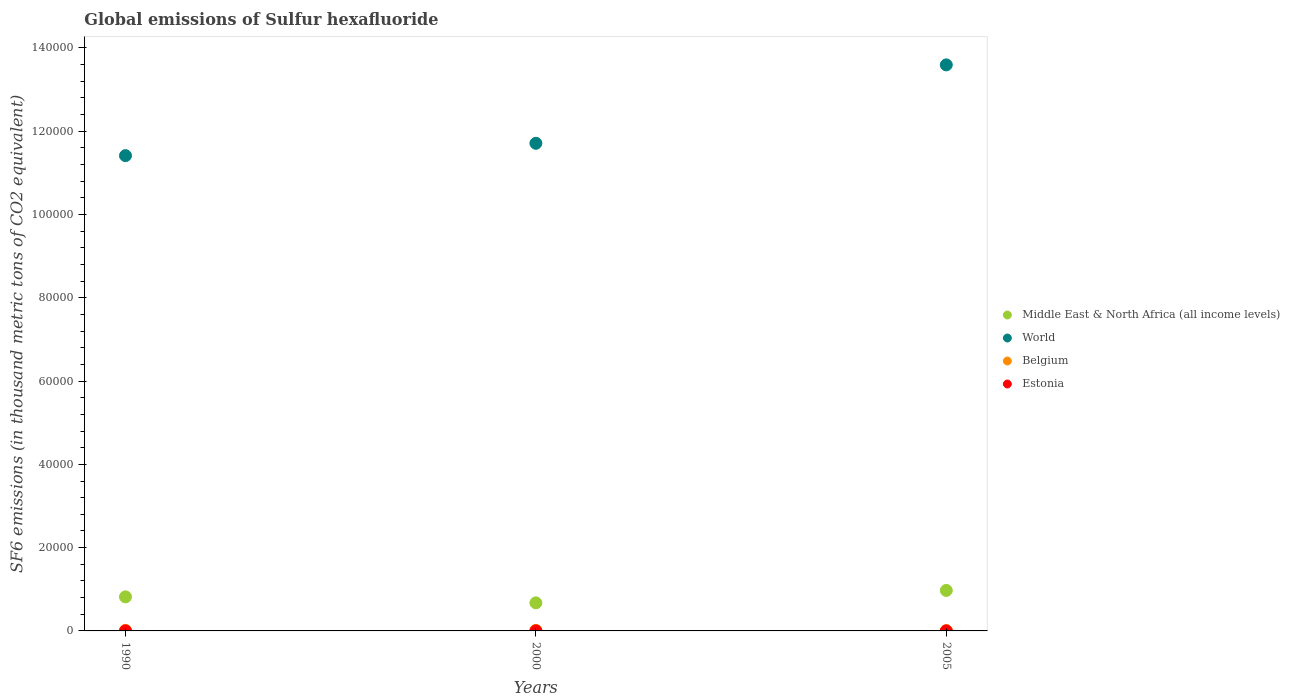Is the number of dotlines equal to the number of legend labels?
Keep it short and to the point. Yes. What is the global emissions of Sulfur hexafluoride in Belgium in 2000?
Offer a terse response. 131.7. Across all years, what is the maximum global emissions of Sulfur hexafluoride in World?
Make the answer very short. 1.36e+05. Across all years, what is the minimum global emissions of Sulfur hexafluoride in Middle East & North Africa (all income levels)?
Your answer should be very brief. 6738.5. In which year was the global emissions of Sulfur hexafluoride in World minimum?
Provide a succinct answer. 1990. What is the total global emissions of Sulfur hexafluoride in Belgium in the graph?
Your answer should be compact. 343.1. What is the difference between the global emissions of Sulfur hexafluoride in Estonia in 1990 and that in 2005?
Offer a very short reply. -0.6. What is the difference between the global emissions of Sulfur hexafluoride in Estonia in 2000 and the global emissions of Sulfur hexafluoride in World in 1990?
Offer a very short reply. -1.14e+05. What is the average global emissions of Sulfur hexafluoride in Belgium per year?
Give a very brief answer. 114.37. In the year 1990, what is the difference between the global emissions of Sulfur hexafluoride in Middle East & North Africa (all income levels) and global emissions of Sulfur hexafluoride in Estonia?
Make the answer very short. 8178.1. What is the ratio of the global emissions of Sulfur hexafluoride in World in 1990 to that in 2005?
Your answer should be compact. 0.84. Is the global emissions of Sulfur hexafluoride in Middle East & North Africa (all income levels) in 1990 less than that in 2000?
Offer a very short reply. No. Is the difference between the global emissions of Sulfur hexafluoride in Middle East & North Africa (all income levels) in 1990 and 2000 greater than the difference between the global emissions of Sulfur hexafluoride in Estonia in 1990 and 2000?
Keep it short and to the point. Yes. What is the difference between the highest and the second highest global emissions of Sulfur hexafluoride in Belgium?
Offer a very short reply. 6.8. What is the difference between the highest and the lowest global emissions of Sulfur hexafluoride in Belgium?
Make the answer very short. 65.6. Is the sum of the global emissions of Sulfur hexafluoride in Belgium in 1990 and 2000 greater than the maximum global emissions of Sulfur hexafluoride in Estonia across all years?
Your answer should be very brief. Yes. Is the global emissions of Sulfur hexafluoride in Belgium strictly greater than the global emissions of Sulfur hexafluoride in Estonia over the years?
Your response must be concise. Yes. Is the global emissions of Sulfur hexafluoride in World strictly less than the global emissions of Sulfur hexafluoride in Belgium over the years?
Keep it short and to the point. No. What is the difference between two consecutive major ticks on the Y-axis?
Keep it short and to the point. 2.00e+04. Are the values on the major ticks of Y-axis written in scientific E-notation?
Make the answer very short. No. Does the graph contain any zero values?
Make the answer very short. No. Does the graph contain grids?
Your answer should be very brief. No. Where does the legend appear in the graph?
Ensure brevity in your answer.  Center right. How many legend labels are there?
Provide a succinct answer. 4. How are the legend labels stacked?
Give a very brief answer. Vertical. What is the title of the graph?
Give a very brief answer. Global emissions of Sulfur hexafluoride. Does "Saudi Arabia" appear as one of the legend labels in the graph?
Offer a very short reply. No. What is the label or title of the X-axis?
Offer a terse response. Years. What is the label or title of the Y-axis?
Make the answer very short. SF6 emissions (in thousand metric tons of CO2 equivalent). What is the SF6 emissions (in thousand metric tons of CO2 equivalent) in Middle East & North Africa (all income levels) in 1990?
Your answer should be very brief. 8179.7. What is the SF6 emissions (in thousand metric tons of CO2 equivalent) of World in 1990?
Offer a very short reply. 1.14e+05. What is the SF6 emissions (in thousand metric tons of CO2 equivalent) of Belgium in 1990?
Your answer should be compact. 138.5. What is the SF6 emissions (in thousand metric tons of CO2 equivalent) in Estonia in 1990?
Keep it short and to the point. 1.6. What is the SF6 emissions (in thousand metric tons of CO2 equivalent) of Middle East & North Africa (all income levels) in 2000?
Offer a very short reply. 6738.5. What is the SF6 emissions (in thousand metric tons of CO2 equivalent) in World in 2000?
Provide a succinct answer. 1.17e+05. What is the SF6 emissions (in thousand metric tons of CO2 equivalent) of Belgium in 2000?
Keep it short and to the point. 131.7. What is the SF6 emissions (in thousand metric tons of CO2 equivalent) of Estonia in 2000?
Offer a terse response. 2. What is the SF6 emissions (in thousand metric tons of CO2 equivalent) of Middle East & North Africa (all income levels) in 2005?
Offer a terse response. 9723.31. What is the SF6 emissions (in thousand metric tons of CO2 equivalent) of World in 2005?
Offer a very short reply. 1.36e+05. What is the SF6 emissions (in thousand metric tons of CO2 equivalent) of Belgium in 2005?
Make the answer very short. 72.9. What is the SF6 emissions (in thousand metric tons of CO2 equivalent) of Estonia in 2005?
Give a very brief answer. 2.2. Across all years, what is the maximum SF6 emissions (in thousand metric tons of CO2 equivalent) of Middle East & North Africa (all income levels)?
Keep it short and to the point. 9723.31. Across all years, what is the maximum SF6 emissions (in thousand metric tons of CO2 equivalent) in World?
Offer a very short reply. 1.36e+05. Across all years, what is the maximum SF6 emissions (in thousand metric tons of CO2 equivalent) of Belgium?
Keep it short and to the point. 138.5. Across all years, what is the minimum SF6 emissions (in thousand metric tons of CO2 equivalent) of Middle East & North Africa (all income levels)?
Provide a succinct answer. 6738.5. Across all years, what is the minimum SF6 emissions (in thousand metric tons of CO2 equivalent) of World?
Provide a succinct answer. 1.14e+05. Across all years, what is the minimum SF6 emissions (in thousand metric tons of CO2 equivalent) of Belgium?
Provide a short and direct response. 72.9. What is the total SF6 emissions (in thousand metric tons of CO2 equivalent) of Middle East & North Africa (all income levels) in the graph?
Provide a succinct answer. 2.46e+04. What is the total SF6 emissions (in thousand metric tons of CO2 equivalent) of World in the graph?
Offer a very short reply. 3.67e+05. What is the total SF6 emissions (in thousand metric tons of CO2 equivalent) of Belgium in the graph?
Your response must be concise. 343.1. What is the total SF6 emissions (in thousand metric tons of CO2 equivalent) in Estonia in the graph?
Your answer should be compact. 5.8. What is the difference between the SF6 emissions (in thousand metric tons of CO2 equivalent) of Middle East & North Africa (all income levels) in 1990 and that in 2000?
Your answer should be compact. 1441.2. What is the difference between the SF6 emissions (in thousand metric tons of CO2 equivalent) of World in 1990 and that in 2000?
Offer a terse response. -2964.6. What is the difference between the SF6 emissions (in thousand metric tons of CO2 equivalent) of Belgium in 1990 and that in 2000?
Your answer should be very brief. 6.8. What is the difference between the SF6 emissions (in thousand metric tons of CO2 equivalent) in Middle East & North Africa (all income levels) in 1990 and that in 2005?
Ensure brevity in your answer.  -1543.61. What is the difference between the SF6 emissions (in thousand metric tons of CO2 equivalent) in World in 1990 and that in 2005?
Your answer should be compact. -2.18e+04. What is the difference between the SF6 emissions (in thousand metric tons of CO2 equivalent) in Belgium in 1990 and that in 2005?
Your response must be concise. 65.6. What is the difference between the SF6 emissions (in thousand metric tons of CO2 equivalent) in Middle East & North Africa (all income levels) in 2000 and that in 2005?
Make the answer very short. -2984.81. What is the difference between the SF6 emissions (in thousand metric tons of CO2 equivalent) of World in 2000 and that in 2005?
Provide a short and direct response. -1.88e+04. What is the difference between the SF6 emissions (in thousand metric tons of CO2 equivalent) of Belgium in 2000 and that in 2005?
Your answer should be compact. 58.8. What is the difference between the SF6 emissions (in thousand metric tons of CO2 equivalent) of Estonia in 2000 and that in 2005?
Make the answer very short. -0.2. What is the difference between the SF6 emissions (in thousand metric tons of CO2 equivalent) of Middle East & North Africa (all income levels) in 1990 and the SF6 emissions (in thousand metric tons of CO2 equivalent) of World in 2000?
Ensure brevity in your answer.  -1.09e+05. What is the difference between the SF6 emissions (in thousand metric tons of CO2 equivalent) of Middle East & North Africa (all income levels) in 1990 and the SF6 emissions (in thousand metric tons of CO2 equivalent) of Belgium in 2000?
Ensure brevity in your answer.  8048. What is the difference between the SF6 emissions (in thousand metric tons of CO2 equivalent) in Middle East & North Africa (all income levels) in 1990 and the SF6 emissions (in thousand metric tons of CO2 equivalent) in Estonia in 2000?
Your answer should be very brief. 8177.7. What is the difference between the SF6 emissions (in thousand metric tons of CO2 equivalent) of World in 1990 and the SF6 emissions (in thousand metric tons of CO2 equivalent) of Belgium in 2000?
Your answer should be compact. 1.14e+05. What is the difference between the SF6 emissions (in thousand metric tons of CO2 equivalent) in World in 1990 and the SF6 emissions (in thousand metric tons of CO2 equivalent) in Estonia in 2000?
Your answer should be very brief. 1.14e+05. What is the difference between the SF6 emissions (in thousand metric tons of CO2 equivalent) in Belgium in 1990 and the SF6 emissions (in thousand metric tons of CO2 equivalent) in Estonia in 2000?
Provide a short and direct response. 136.5. What is the difference between the SF6 emissions (in thousand metric tons of CO2 equivalent) in Middle East & North Africa (all income levels) in 1990 and the SF6 emissions (in thousand metric tons of CO2 equivalent) in World in 2005?
Your answer should be compact. -1.28e+05. What is the difference between the SF6 emissions (in thousand metric tons of CO2 equivalent) of Middle East & North Africa (all income levels) in 1990 and the SF6 emissions (in thousand metric tons of CO2 equivalent) of Belgium in 2005?
Make the answer very short. 8106.8. What is the difference between the SF6 emissions (in thousand metric tons of CO2 equivalent) in Middle East & North Africa (all income levels) in 1990 and the SF6 emissions (in thousand metric tons of CO2 equivalent) in Estonia in 2005?
Offer a terse response. 8177.5. What is the difference between the SF6 emissions (in thousand metric tons of CO2 equivalent) in World in 1990 and the SF6 emissions (in thousand metric tons of CO2 equivalent) in Belgium in 2005?
Make the answer very short. 1.14e+05. What is the difference between the SF6 emissions (in thousand metric tons of CO2 equivalent) in World in 1990 and the SF6 emissions (in thousand metric tons of CO2 equivalent) in Estonia in 2005?
Your response must be concise. 1.14e+05. What is the difference between the SF6 emissions (in thousand metric tons of CO2 equivalent) in Belgium in 1990 and the SF6 emissions (in thousand metric tons of CO2 equivalent) in Estonia in 2005?
Offer a very short reply. 136.3. What is the difference between the SF6 emissions (in thousand metric tons of CO2 equivalent) in Middle East & North Africa (all income levels) in 2000 and the SF6 emissions (in thousand metric tons of CO2 equivalent) in World in 2005?
Give a very brief answer. -1.29e+05. What is the difference between the SF6 emissions (in thousand metric tons of CO2 equivalent) of Middle East & North Africa (all income levels) in 2000 and the SF6 emissions (in thousand metric tons of CO2 equivalent) of Belgium in 2005?
Make the answer very short. 6665.6. What is the difference between the SF6 emissions (in thousand metric tons of CO2 equivalent) in Middle East & North Africa (all income levels) in 2000 and the SF6 emissions (in thousand metric tons of CO2 equivalent) in Estonia in 2005?
Make the answer very short. 6736.3. What is the difference between the SF6 emissions (in thousand metric tons of CO2 equivalent) in World in 2000 and the SF6 emissions (in thousand metric tons of CO2 equivalent) in Belgium in 2005?
Provide a short and direct response. 1.17e+05. What is the difference between the SF6 emissions (in thousand metric tons of CO2 equivalent) in World in 2000 and the SF6 emissions (in thousand metric tons of CO2 equivalent) in Estonia in 2005?
Offer a terse response. 1.17e+05. What is the difference between the SF6 emissions (in thousand metric tons of CO2 equivalent) of Belgium in 2000 and the SF6 emissions (in thousand metric tons of CO2 equivalent) of Estonia in 2005?
Make the answer very short. 129.5. What is the average SF6 emissions (in thousand metric tons of CO2 equivalent) of Middle East & North Africa (all income levels) per year?
Offer a very short reply. 8213.84. What is the average SF6 emissions (in thousand metric tons of CO2 equivalent) of World per year?
Give a very brief answer. 1.22e+05. What is the average SF6 emissions (in thousand metric tons of CO2 equivalent) of Belgium per year?
Offer a very short reply. 114.37. What is the average SF6 emissions (in thousand metric tons of CO2 equivalent) of Estonia per year?
Offer a very short reply. 1.93. In the year 1990, what is the difference between the SF6 emissions (in thousand metric tons of CO2 equivalent) of Middle East & North Africa (all income levels) and SF6 emissions (in thousand metric tons of CO2 equivalent) of World?
Keep it short and to the point. -1.06e+05. In the year 1990, what is the difference between the SF6 emissions (in thousand metric tons of CO2 equivalent) of Middle East & North Africa (all income levels) and SF6 emissions (in thousand metric tons of CO2 equivalent) of Belgium?
Ensure brevity in your answer.  8041.2. In the year 1990, what is the difference between the SF6 emissions (in thousand metric tons of CO2 equivalent) of Middle East & North Africa (all income levels) and SF6 emissions (in thousand metric tons of CO2 equivalent) of Estonia?
Give a very brief answer. 8178.1. In the year 1990, what is the difference between the SF6 emissions (in thousand metric tons of CO2 equivalent) in World and SF6 emissions (in thousand metric tons of CO2 equivalent) in Belgium?
Ensure brevity in your answer.  1.14e+05. In the year 1990, what is the difference between the SF6 emissions (in thousand metric tons of CO2 equivalent) in World and SF6 emissions (in thousand metric tons of CO2 equivalent) in Estonia?
Offer a terse response. 1.14e+05. In the year 1990, what is the difference between the SF6 emissions (in thousand metric tons of CO2 equivalent) of Belgium and SF6 emissions (in thousand metric tons of CO2 equivalent) of Estonia?
Give a very brief answer. 136.9. In the year 2000, what is the difference between the SF6 emissions (in thousand metric tons of CO2 equivalent) in Middle East & North Africa (all income levels) and SF6 emissions (in thousand metric tons of CO2 equivalent) in World?
Your response must be concise. -1.10e+05. In the year 2000, what is the difference between the SF6 emissions (in thousand metric tons of CO2 equivalent) in Middle East & North Africa (all income levels) and SF6 emissions (in thousand metric tons of CO2 equivalent) in Belgium?
Your answer should be compact. 6606.8. In the year 2000, what is the difference between the SF6 emissions (in thousand metric tons of CO2 equivalent) of Middle East & North Africa (all income levels) and SF6 emissions (in thousand metric tons of CO2 equivalent) of Estonia?
Offer a terse response. 6736.5. In the year 2000, what is the difference between the SF6 emissions (in thousand metric tons of CO2 equivalent) in World and SF6 emissions (in thousand metric tons of CO2 equivalent) in Belgium?
Make the answer very short. 1.17e+05. In the year 2000, what is the difference between the SF6 emissions (in thousand metric tons of CO2 equivalent) of World and SF6 emissions (in thousand metric tons of CO2 equivalent) of Estonia?
Give a very brief answer. 1.17e+05. In the year 2000, what is the difference between the SF6 emissions (in thousand metric tons of CO2 equivalent) in Belgium and SF6 emissions (in thousand metric tons of CO2 equivalent) in Estonia?
Give a very brief answer. 129.7. In the year 2005, what is the difference between the SF6 emissions (in thousand metric tons of CO2 equivalent) of Middle East & North Africa (all income levels) and SF6 emissions (in thousand metric tons of CO2 equivalent) of World?
Give a very brief answer. -1.26e+05. In the year 2005, what is the difference between the SF6 emissions (in thousand metric tons of CO2 equivalent) of Middle East & North Africa (all income levels) and SF6 emissions (in thousand metric tons of CO2 equivalent) of Belgium?
Offer a terse response. 9650.41. In the year 2005, what is the difference between the SF6 emissions (in thousand metric tons of CO2 equivalent) of Middle East & North Africa (all income levels) and SF6 emissions (in thousand metric tons of CO2 equivalent) of Estonia?
Your answer should be very brief. 9721.11. In the year 2005, what is the difference between the SF6 emissions (in thousand metric tons of CO2 equivalent) of World and SF6 emissions (in thousand metric tons of CO2 equivalent) of Belgium?
Provide a short and direct response. 1.36e+05. In the year 2005, what is the difference between the SF6 emissions (in thousand metric tons of CO2 equivalent) of World and SF6 emissions (in thousand metric tons of CO2 equivalent) of Estonia?
Make the answer very short. 1.36e+05. In the year 2005, what is the difference between the SF6 emissions (in thousand metric tons of CO2 equivalent) in Belgium and SF6 emissions (in thousand metric tons of CO2 equivalent) in Estonia?
Offer a very short reply. 70.7. What is the ratio of the SF6 emissions (in thousand metric tons of CO2 equivalent) in Middle East & North Africa (all income levels) in 1990 to that in 2000?
Your answer should be compact. 1.21. What is the ratio of the SF6 emissions (in thousand metric tons of CO2 equivalent) of World in 1990 to that in 2000?
Your answer should be compact. 0.97. What is the ratio of the SF6 emissions (in thousand metric tons of CO2 equivalent) of Belgium in 1990 to that in 2000?
Your response must be concise. 1.05. What is the ratio of the SF6 emissions (in thousand metric tons of CO2 equivalent) in Estonia in 1990 to that in 2000?
Keep it short and to the point. 0.8. What is the ratio of the SF6 emissions (in thousand metric tons of CO2 equivalent) of Middle East & North Africa (all income levels) in 1990 to that in 2005?
Your response must be concise. 0.84. What is the ratio of the SF6 emissions (in thousand metric tons of CO2 equivalent) of World in 1990 to that in 2005?
Your answer should be very brief. 0.84. What is the ratio of the SF6 emissions (in thousand metric tons of CO2 equivalent) in Belgium in 1990 to that in 2005?
Keep it short and to the point. 1.9. What is the ratio of the SF6 emissions (in thousand metric tons of CO2 equivalent) of Estonia in 1990 to that in 2005?
Your answer should be very brief. 0.73. What is the ratio of the SF6 emissions (in thousand metric tons of CO2 equivalent) in Middle East & North Africa (all income levels) in 2000 to that in 2005?
Provide a succinct answer. 0.69. What is the ratio of the SF6 emissions (in thousand metric tons of CO2 equivalent) in World in 2000 to that in 2005?
Ensure brevity in your answer.  0.86. What is the ratio of the SF6 emissions (in thousand metric tons of CO2 equivalent) of Belgium in 2000 to that in 2005?
Your answer should be compact. 1.81. What is the difference between the highest and the second highest SF6 emissions (in thousand metric tons of CO2 equivalent) of Middle East & North Africa (all income levels)?
Ensure brevity in your answer.  1543.61. What is the difference between the highest and the second highest SF6 emissions (in thousand metric tons of CO2 equivalent) in World?
Offer a very short reply. 1.88e+04. What is the difference between the highest and the second highest SF6 emissions (in thousand metric tons of CO2 equivalent) in Estonia?
Provide a succinct answer. 0.2. What is the difference between the highest and the lowest SF6 emissions (in thousand metric tons of CO2 equivalent) in Middle East & North Africa (all income levels)?
Offer a terse response. 2984.81. What is the difference between the highest and the lowest SF6 emissions (in thousand metric tons of CO2 equivalent) of World?
Offer a very short reply. 2.18e+04. What is the difference between the highest and the lowest SF6 emissions (in thousand metric tons of CO2 equivalent) of Belgium?
Your response must be concise. 65.6. 